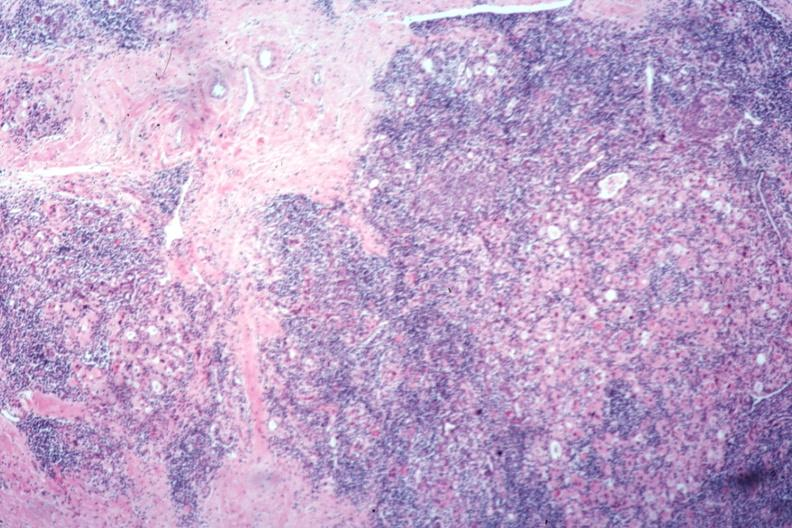what does this image show?
Answer the question using a single word or phrase. Typical severe hashimotos no thyroid tissue recognizable 